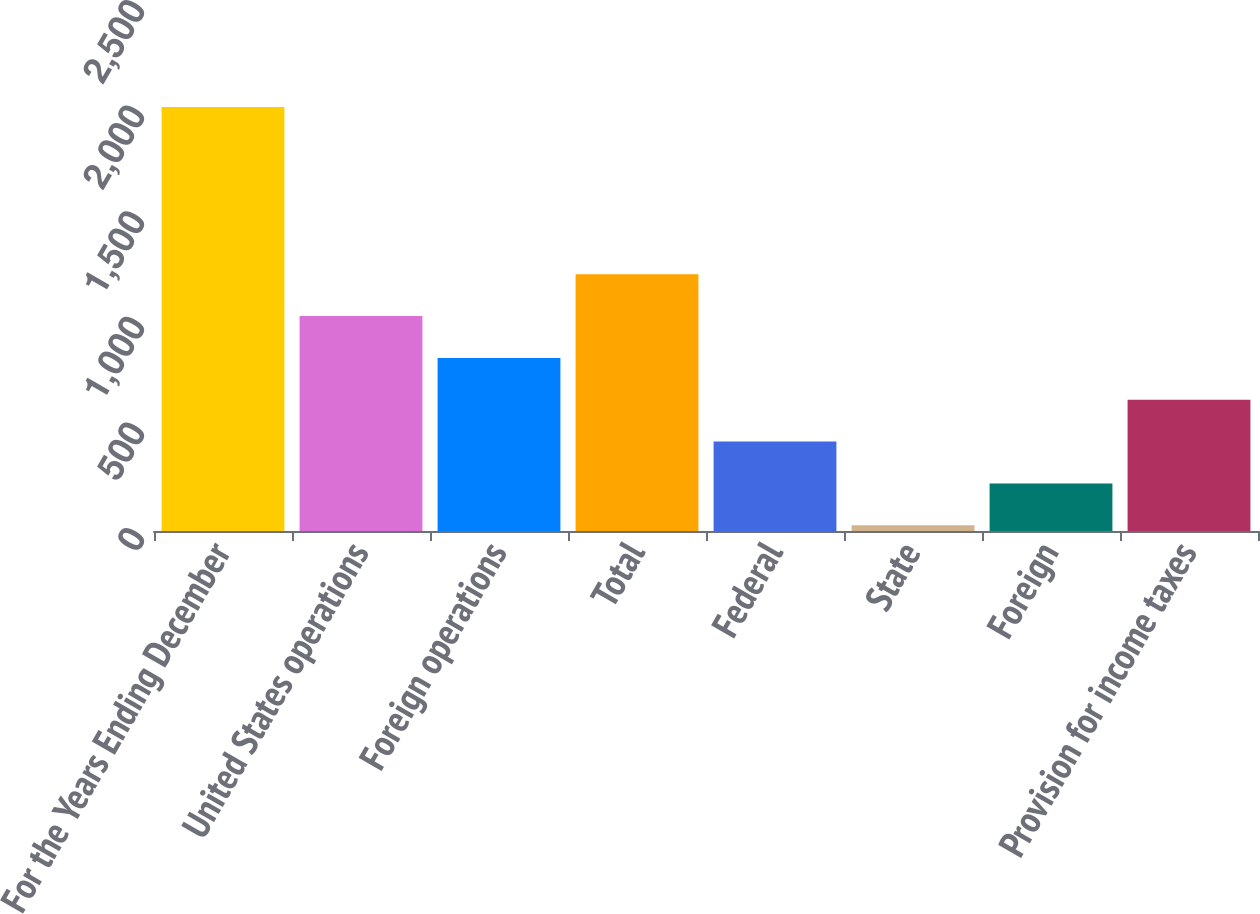Convert chart. <chart><loc_0><loc_0><loc_500><loc_500><bar_chart><fcel>For the Years Ending December<fcel>United States operations<fcel>Foreign operations<fcel>Total<fcel>Federal<fcel>State<fcel>Foreign<fcel>Provision for income taxes<nl><fcel>2008<fcel>1017.65<fcel>819.58<fcel>1215.72<fcel>423.44<fcel>27.3<fcel>225.37<fcel>621.51<nl></chart> 